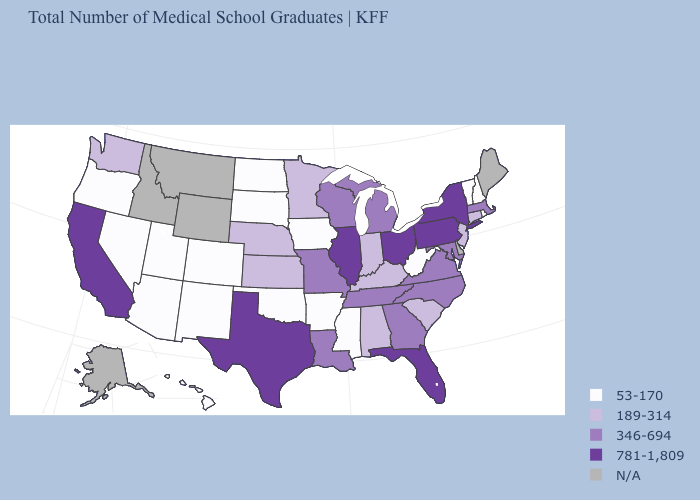What is the value of California?
Answer briefly. 781-1,809. Does the first symbol in the legend represent the smallest category?
Give a very brief answer. Yes. Is the legend a continuous bar?
Give a very brief answer. No. Name the states that have a value in the range 346-694?
Be succinct. Georgia, Louisiana, Maryland, Massachusetts, Michigan, Missouri, North Carolina, Tennessee, Virginia, Wisconsin. Which states have the lowest value in the USA?
Keep it brief. Arizona, Arkansas, Colorado, Hawaii, Iowa, Mississippi, Nevada, New Hampshire, New Mexico, North Dakota, Oklahoma, Oregon, Rhode Island, South Dakota, Utah, Vermont, West Virginia. What is the value of Illinois?
Be succinct. 781-1,809. Which states have the lowest value in the USA?
Keep it brief. Arizona, Arkansas, Colorado, Hawaii, Iowa, Mississippi, Nevada, New Hampshire, New Mexico, North Dakota, Oklahoma, Oregon, Rhode Island, South Dakota, Utah, Vermont, West Virginia. Among the states that border South Carolina , which have the lowest value?
Keep it brief. Georgia, North Carolina. Name the states that have a value in the range 781-1,809?
Keep it brief. California, Florida, Illinois, New York, Ohio, Pennsylvania, Texas. Among the states that border Kentucky , which have the highest value?
Short answer required. Illinois, Ohio. What is the value of Maryland?
Give a very brief answer. 346-694. What is the highest value in states that border Vermont?
Answer briefly. 781-1,809. Does the map have missing data?
Answer briefly. Yes. 